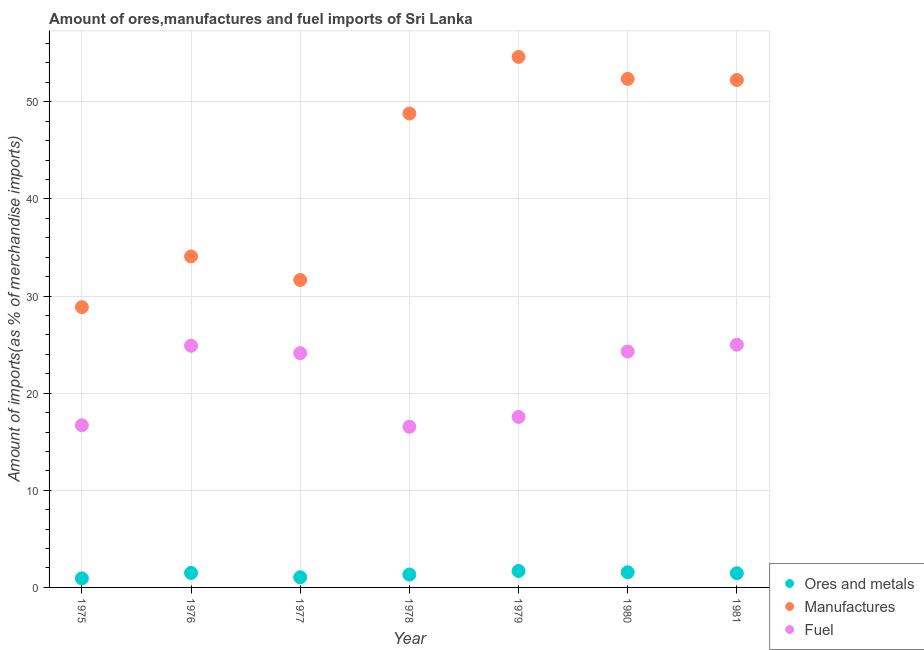Is the number of dotlines equal to the number of legend labels?
Keep it short and to the point. Yes. What is the percentage of manufactures imports in 1979?
Provide a succinct answer. 54.61. Across all years, what is the maximum percentage of ores and metals imports?
Your answer should be very brief. 1.69. Across all years, what is the minimum percentage of fuel imports?
Provide a short and direct response. 16.54. In which year was the percentage of fuel imports maximum?
Your response must be concise. 1981. In which year was the percentage of ores and metals imports minimum?
Make the answer very short. 1975. What is the total percentage of ores and metals imports in the graph?
Make the answer very short. 9.52. What is the difference between the percentage of ores and metals imports in 1977 and that in 1978?
Keep it short and to the point. -0.28. What is the difference between the percentage of ores and metals imports in 1981 and the percentage of fuel imports in 1980?
Provide a short and direct response. -22.83. What is the average percentage of manufactures imports per year?
Keep it short and to the point. 43.22. In the year 1977, what is the difference between the percentage of ores and metals imports and percentage of manufactures imports?
Make the answer very short. -30.6. What is the ratio of the percentage of manufactures imports in 1975 to that in 1980?
Give a very brief answer. 0.55. Is the percentage of fuel imports in 1978 less than that in 1979?
Your answer should be very brief. Yes. What is the difference between the highest and the second highest percentage of fuel imports?
Provide a short and direct response. 0.1. What is the difference between the highest and the lowest percentage of ores and metals imports?
Keep it short and to the point. 0.76. In how many years, is the percentage of fuel imports greater than the average percentage of fuel imports taken over all years?
Give a very brief answer. 4. Is the sum of the percentage of fuel imports in 1975 and 1977 greater than the maximum percentage of ores and metals imports across all years?
Provide a short and direct response. Yes. Does the percentage of ores and metals imports monotonically increase over the years?
Make the answer very short. No. Does the graph contain any zero values?
Ensure brevity in your answer.  No. Where does the legend appear in the graph?
Provide a short and direct response. Bottom right. What is the title of the graph?
Keep it short and to the point. Amount of ores,manufactures and fuel imports of Sri Lanka. What is the label or title of the X-axis?
Give a very brief answer. Year. What is the label or title of the Y-axis?
Provide a succinct answer. Amount of imports(as % of merchandise imports). What is the Amount of imports(as % of merchandise imports) in Ores and metals in 1975?
Provide a succinct answer. 0.93. What is the Amount of imports(as % of merchandise imports) in Manufactures in 1975?
Your answer should be very brief. 28.85. What is the Amount of imports(as % of merchandise imports) of Fuel in 1975?
Offer a very short reply. 16.69. What is the Amount of imports(as % of merchandise imports) in Ores and metals in 1976?
Give a very brief answer. 1.49. What is the Amount of imports(as % of merchandise imports) in Manufactures in 1976?
Offer a terse response. 34.07. What is the Amount of imports(as % of merchandise imports) of Fuel in 1976?
Make the answer very short. 24.88. What is the Amount of imports(as % of merchandise imports) in Ores and metals in 1977?
Ensure brevity in your answer.  1.05. What is the Amount of imports(as % of merchandise imports) in Manufactures in 1977?
Offer a terse response. 31.65. What is the Amount of imports(as % of merchandise imports) in Fuel in 1977?
Provide a short and direct response. 24.12. What is the Amount of imports(as % of merchandise imports) of Ores and metals in 1978?
Give a very brief answer. 1.33. What is the Amount of imports(as % of merchandise imports) in Manufactures in 1978?
Your answer should be very brief. 48.78. What is the Amount of imports(as % of merchandise imports) in Fuel in 1978?
Ensure brevity in your answer.  16.54. What is the Amount of imports(as % of merchandise imports) in Ores and metals in 1979?
Make the answer very short. 1.69. What is the Amount of imports(as % of merchandise imports) in Manufactures in 1979?
Ensure brevity in your answer.  54.61. What is the Amount of imports(as % of merchandise imports) of Fuel in 1979?
Ensure brevity in your answer.  17.55. What is the Amount of imports(as % of merchandise imports) of Ores and metals in 1980?
Offer a very short reply. 1.56. What is the Amount of imports(as % of merchandise imports) of Manufactures in 1980?
Provide a short and direct response. 52.35. What is the Amount of imports(as % of merchandise imports) in Fuel in 1980?
Provide a short and direct response. 24.29. What is the Amount of imports(as % of merchandise imports) of Ores and metals in 1981?
Ensure brevity in your answer.  1.46. What is the Amount of imports(as % of merchandise imports) in Manufactures in 1981?
Offer a very short reply. 52.24. What is the Amount of imports(as % of merchandise imports) of Fuel in 1981?
Ensure brevity in your answer.  24.98. Across all years, what is the maximum Amount of imports(as % of merchandise imports) of Ores and metals?
Provide a succinct answer. 1.69. Across all years, what is the maximum Amount of imports(as % of merchandise imports) in Manufactures?
Provide a short and direct response. 54.61. Across all years, what is the maximum Amount of imports(as % of merchandise imports) in Fuel?
Provide a succinct answer. 24.98. Across all years, what is the minimum Amount of imports(as % of merchandise imports) in Ores and metals?
Offer a very short reply. 0.93. Across all years, what is the minimum Amount of imports(as % of merchandise imports) in Manufactures?
Your answer should be very brief. 28.85. Across all years, what is the minimum Amount of imports(as % of merchandise imports) of Fuel?
Make the answer very short. 16.54. What is the total Amount of imports(as % of merchandise imports) of Ores and metals in the graph?
Give a very brief answer. 9.52. What is the total Amount of imports(as % of merchandise imports) in Manufactures in the graph?
Provide a short and direct response. 302.56. What is the total Amount of imports(as % of merchandise imports) of Fuel in the graph?
Provide a succinct answer. 149.04. What is the difference between the Amount of imports(as % of merchandise imports) in Ores and metals in 1975 and that in 1976?
Offer a terse response. -0.56. What is the difference between the Amount of imports(as % of merchandise imports) in Manufactures in 1975 and that in 1976?
Provide a short and direct response. -5.22. What is the difference between the Amount of imports(as % of merchandise imports) of Fuel in 1975 and that in 1976?
Make the answer very short. -8.19. What is the difference between the Amount of imports(as % of merchandise imports) in Ores and metals in 1975 and that in 1977?
Ensure brevity in your answer.  -0.11. What is the difference between the Amount of imports(as % of merchandise imports) of Manufactures in 1975 and that in 1977?
Keep it short and to the point. -2.8. What is the difference between the Amount of imports(as % of merchandise imports) of Fuel in 1975 and that in 1977?
Your answer should be compact. -7.43. What is the difference between the Amount of imports(as % of merchandise imports) in Ores and metals in 1975 and that in 1978?
Your response must be concise. -0.4. What is the difference between the Amount of imports(as % of merchandise imports) in Manufactures in 1975 and that in 1978?
Offer a very short reply. -19.93. What is the difference between the Amount of imports(as % of merchandise imports) of Fuel in 1975 and that in 1978?
Give a very brief answer. 0.15. What is the difference between the Amount of imports(as % of merchandise imports) of Ores and metals in 1975 and that in 1979?
Offer a very short reply. -0.76. What is the difference between the Amount of imports(as % of merchandise imports) in Manufactures in 1975 and that in 1979?
Your response must be concise. -25.76. What is the difference between the Amount of imports(as % of merchandise imports) of Fuel in 1975 and that in 1979?
Your response must be concise. -0.86. What is the difference between the Amount of imports(as % of merchandise imports) of Ores and metals in 1975 and that in 1980?
Provide a succinct answer. -0.63. What is the difference between the Amount of imports(as % of merchandise imports) in Manufactures in 1975 and that in 1980?
Provide a succinct answer. -23.5. What is the difference between the Amount of imports(as % of merchandise imports) in Fuel in 1975 and that in 1980?
Your response must be concise. -7.6. What is the difference between the Amount of imports(as % of merchandise imports) of Ores and metals in 1975 and that in 1981?
Ensure brevity in your answer.  -0.53. What is the difference between the Amount of imports(as % of merchandise imports) of Manufactures in 1975 and that in 1981?
Provide a short and direct response. -23.38. What is the difference between the Amount of imports(as % of merchandise imports) in Fuel in 1975 and that in 1981?
Provide a short and direct response. -8.29. What is the difference between the Amount of imports(as % of merchandise imports) in Ores and metals in 1976 and that in 1977?
Your answer should be very brief. 0.44. What is the difference between the Amount of imports(as % of merchandise imports) in Manufactures in 1976 and that in 1977?
Provide a short and direct response. 2.43. What is the difference between the Amount of imports(as % of merchandise imports) of Fuel in 1976 and that in 1977?
Keep it short and to the point. 0.76. What is the difference between the Amount of imports(as % of merchandise imports) of Ores and metals in 1976 and that in 1978?
Keep it short and to the point. 0.16. What is the difference between the Amount of imports(as % of merchandise imports) in Manufactures in 1976 and that in 1978?
Provide a succinct answer. -14.71. What is the difference between the Amount of imports(as % of merchandise imports) in Fuel in 1976 and that in 1978?
Offer a terse response. 8.34. What is the difference between the Amount of imports(as % of merchandise imports) of Ores and metals in 1976 and that in 1979?
Provide a succinct answer. -0.2. What is the difference between the Amount of imports(as % of merchandise imports) in Manufactures in 1976 and that in 1979?
Your answer should be very brief. -20.54. What is the difference between the Amount of imports(as % of merchandise imports) of Fuel in 1976 and that in 1979?
Offer a very short reply. 7.33. What is the difference between the Amount of imports(as % of merchandise imports) of Ores and metals in 1976 and that in 1980?
Provide a succinct answer. -0.07. What is the difference between the Amount of imports(as % of merchandise imports) in Manufactures in 1976 and that in 1980?
Offer a very short reply. -18.27. What is the difference between the Amount of imports(as % of merchandise imports) of Fuel in 1976 and that in 1980?
Offer a terse response. 0.59. What is the difference between the Amount of imports(as % of merchandise imports) of Ores and metals in 1976 and that in 1981?
Provide a short and direct response. 0.03. What is the difference between the Amount of imports(as % of merchandise imports) of Manufactures in 1976 and that in 1981?
Keep it short and to the point. -18.16. What is the difference between the Amount of imports(as % of merchandise imports) in Fuel in 1976 and that in 1981?
Your answer should be compact. -0.1. What is the difference between the Amount of imports(as % of merchandise imports) in Ores and metals in 1977 and that in 1978?
Your response must be concise. -0.28. What is the difference between the Amount of imports(as % of merchandise imports) of Manufactures in 1977 and that in 1978?
Offer a very short reply. -17.13. What is the difference between the Amount of imports(as % of merchandise imports) in Fuel in 1977 and that in 1978?
Your answer should be compact. 7.58. What is the difference between the Amount of imports(as % of merchandise imports) of Ores and metals in 1977 and that in 1979?
Give a very brief answer. -0.65. What is the difference between the Amount of imports(as % of merchandise imports) in Manufactures in 1977 and that in 1979?
Ensure brevity in your answer.  -22.97. What is the difference between the Amount of imports(as % of merchandise imports) in Fuel in 1977 and that in 1979?
Offer a terse response. 6.57. What is the difference between the Amount of imports(as % of merchandise imports) in Ores and metals in 1977 and that in 1980?
Offer a very short reply. -0.51. What is the difference between the Amount of imports(as % of merchandise imports) in Manufactures in 1977 and that in 1980?
Offer a terse response. -20.7. What is the difference between the Amount of imports(as % of merchandise imports) in Fuel in 1977 and that in 1980?
Make the answer very short. -0.17. What is the difference between the Amount of imports(as % of merchandise imports) in Ores and metals in 1977 and that in 1981?
Make the answer very short. -0.42. What is the difference between the Amount of imports(as % of merchandise imports) in Manufactures in 1977 and that in 1981?
Give a very brief answer. -20.59. What is the difference between the Amount of imports(as % of merchandise imports) of Fuel in 1977 and that in 1981?
Offer a very short reply. -0.87. What is the difference between the Amount of imports(as % of merchandise imports) in Ores and metals in 1978 and that in 1979?
Offer a terse response. -0.36. What is the difference between the Amount of imports(as % of merchandise imports) of Manufactures in 1978 and that in 1979?
Your response must be concise. -5.83. What is the difference between the Amount of imports(as % of merchandise imports) in Fuel in 1978 and that in 1979?
Your answer should be compact. -1.01. What is the difference between the Amount of imports(as % of merchandise imports) of Ores and metals in 1978 and that in 1980?
Provide a short and direct response. -0.23. What is the difference between the Amount of imports(as % of merchandise imports) of Manufactures in 1978 and that in 1980?
Keep it short and to the point. -3.57. What is the difference between the Amount of imports(as % of merchandise imports) in Fuel in 1978 and that in 1980?
Ensure brevity in your answer.  -7.75. What is the difference between the Amount of imports(as % of merchandise imports) of Ores and metals in 1978 and that in 1981?
Your answer should be compact. -0.13. What is the difference between the Amount of imports(as % of merchandise imports) in Manufactures in 1978 and that in 1981?
Make the answer very short. -3.45. What is the difference between the Amount of imports(as % of merchandise imports) of Fuel in 1978 and that in 1981?
Your answer should be very brief. -8.44. What is the difference between the Amount of imports(as % of merchandise imports) of Ores and metals in 1979 and that in 1980?
Make the answer very short. 0.13. What is the difference between the Amount of imports(as % of merchandise imports) of Manufactures in 1979 and that in 1980?
Give a very brief answer. 2.27. What is the difference between the Amount of imports(as % of merchandise imports) of Fuel in 1979 and that in 1980?
Offer a terse response. -6.74. What is the difference between the Amount of imports(as % of merchandise imports) of Ores and metals in 1979 and that in 1981?
Your answer should be compact. 0.23. What is the difference between the Amount of imports(as % of merchandise imports) of Manufactures in 1979 and that in 1981?
Ensure brevity in your answer.  2.38. What is the difference between the Amount of imports(as % of merchandise imports) in Fuel in 1979 and that in 1981?
Give a very brief answer. -7.43. What is the difference between the Amount of imports(as % of merchandise imports) of Ores and metals in 1980 and that in 1981?
Offer a very short reply. 0.1. What is the difference between the Amount of imports(as % of merchandise imports) in Manufactures in 1980 and that in 1981?
Provide a succinct answer. 0.11. What is the difference between the Amount of imports(as % of merchandise imports) in Fuel in 1980 and that in 1981?
Make the answer very short. -0.69. What is the difference between the Amount of imports(as % of merchandise imports) of Ores and metals in 1975 and the Amount of imports(as % of merchandise imports) of Manufactures in 1976?
Provide a succinct answer. -33.14. What is the difference between the Amount of imports(as % of merchandise imports) of Ores and metals in 1975 and the Amount of imports(as % of merchandise imports) of Fuel in 1976?
Provide a succinct answer. -23.95. What is the difference between the Amount of imports(as % of merchandise imports) in Manufactures in 1975 and the Amount of imports(as % of merchandise imports) in Fuel in 1976?
Your response must be concise. 3.97. What is the difference between the Amount of imports(as % of merchandise imports) of Ores and metals in 1975 and the Amount of imports(as % of merchandise imports) of Manufactures in 1977?
Provide a short and direct response. -30.72. What is the difference between the Amount of imports(as % of merchandise imports) of Ores and metals in 1975 and the Amount of imports(as % of merchandise imports) of Fuel in 1977?
Provide a succinct answer. -23.18. What is the difference between the Amount of imports(as % of merchandise imports) of Manufactures in 1975 and the Amount of imports(as % of merchandise imports) of Fuel in 1977?
Your answer should be very brief. 4.74. What is the difference between the Amount of imports(as % of merchandise imports) of Ores and metals in 1975 and the Amount of imports(as % of merchandise imports) of Manufactures in 1978?
Offer a terse response. -47.85. What is the difference between the Amount of imports(as % of merchandise imports) in Ores and metals in 1975 and the Amount of imports(as % of merchandise imports) in Fuel in 1978?
Offer a very short reply. -15.61. What is the difference between the Amount of imports(as % of merchandise imports) in Manufactures in 1975 and the Amount of imports(as % of merchandise imports) in Fuel in 1978?
Your answer should be compact. 12.31. What is the difference between the Amount of imports(as % of merchandise imports) of Ores and metals in 1975 and the Amount of imports(as % of merchandise imports) of Manufactures in 1979?
Your answer should be very brief. -53.68. What is the difference between the Amount of imports(as % of merchandise imports) of Ores and metals in 1975 and the Amount of imports(as % of merchandise imports) of Fuel in 1979?
Ensure brevity in your answer.  -16.62. What is the difference between the Amount of imports(as % of merchandise imports) in Manufactures in 1975 and the Amount of imports(as % of merchandise imports) in Fuel in 1979?
Your answer should be compact. 11.3. What is the difference between the Amount of imports(as % of merchandise imports) of Ores and metals in 1975 and the Amount of imports(as % of merchandise imports) of Manufactures in 1980?
Give a very brief answer. -51.42. What is the difference between the Amount of imports(as % of merchandise imports) of Ores and metals in 1975 and the Amount of imports(as % of merchandise imports) of Fuel in 1980?
Your response must be concise. -23.36. What is the difference between the Amount of imports(as % of merchandise imports) of Manufactures in 1975 and the Amount of imports(as % of merchandise imports) of Fuel in 1980?
Give a very brief answer. 4.56. What is the difference between the Amount of imports(as % of merchandise imports) of Ores and metals in 1975 and the Amount of imports(as % of merchandise imports) of Manufactures in 1981?
Keep it short and to the point. -51.3. What is the difference between the Amount of imports(as % of merchandise imports) in Ores and metals in 1975 and the Amount of imports(as % of merchandise imports) in Fuel in 1981?
Offer a very short reply. -24.05. What is the difference between the Amount of imports(as % of merchandise imports) in Manufactures in 1975 and the Amount of imports(as % of merchandise imports) in Fuel in 1981?
Make the answer very short. 3.87. What is the difference between the Amount of imports(as % of merchandise imports) in Ores and metals in 1976 and the Amount of imports(as % of merchandise imports) in Manufactures in 1977?
Your answer should be very brief. -30.16. What is the difference between the Amount of imports(as % of merchandise imports) of Ores and metals in 1976 and the Amount of imports(as % of merchandise imports) of Fuel in 1977?
Ensure brevity in your answer.  -22.62. What is the difference between the Amount of imports(as % of merchandise imports) in Manufactures in 1976 and the Amount of imports(as % of merchandise imports) in Fuel in 1977?
Your answer should be compact. 9.96. What is the difference between the Amount of imports(as % of merchandise imports) of Ores and metals in 1976 and the Amount of imports(as % of merchandise imports) of Manufactures in 1978?
Offer a very short reply. -47.29. What is the difference between the Amount of imports(as % of merchandise imports) of Ores and metals in 1976 and the Amount of imports(as % of merchandise imports) of Fuel in 1978?
Provide a succinct answer. -15.05. What is the difference between the Amount of imports(as % of merchandise imports) of Manufactures in 1976 and the Amount of imports(as % of merchandise imports) of Fuel in 1978?
Offer a terse response. 17.54. What is the difference between the Amount of imports(as % of merchandise imports) of Ores and metals in 1976 and the Amount of imports(as % of merchandise imports) of Manufactures in 1979?
Ensure brevity in your answer.  -53.12. What is the difference between the Amount of imports(as % of merchandise imports) of Ores and metals in 1976 and the Amount of imports(as % of merchandise imports) of Fuel in 1979?
Offer a terse response. -16.06. What is the difference between the Amount of imports(as % of merchandise imports) of Manufactures in 1976 and the Amount of imports(as % of merchandise imports) of Fuel in 1979?
Your answer should be very brief. 16.52. What is the difference between the Amount of imports(as % of merchandise imports) of Ores and metals in 1976 and the Amount of imports(as % of merchandise imports) of Manufactures in 1980?
Offer a very short reply. -50.86. What is the difference between the Amount of imports(as % of merchandise imports) of Ores and metals in 1976 and the Amount of imports(as % of merchandise imports) of Fuel in 1980?
Your response must be concise. -22.8. What is the difference between the Amount of imports(as % of merchandise imports) of Manufactures in 1976 and the Amount of imports(as % of merchandise imports) of Fuel in 1980?
Keep it short and to the point. 9.78. What is the difference between the Amount of imports(as % of merchandise imports) in Ores and metals in 1976 and the Amount of imports(as % of merchandise imports) in Manufactures in 1981?
Your answer should be compact. -50.75. What is the difference between the Amount of imports(as % of merchandise imports) in Ores and metals in 1976 and the Amount of imports(as % of merchandise imports) in Fuel in 1981?
Offer a very short reply. -23.49. What is the difference between the Amount of imports(as % of merchandise imports) of Manufactures in 1976 and the Amount of imports(as % of merchandise imports) of Fuel in 1981?
Make the answer very short. 9.09. What is the difference between the Amount of imports(as % of merchandise imports) in Ores and metals in 1977 and the Amount of imports(as % of merchandise imports) in Manufactures in 1978?
Offer a very short reply. -47.74. What is the difference between the Amount of imports(as % of merchandise imports) of Ores and metals in 1977 and the Amount of imports(as % of merchandise imports) of Fuel in 1978?
Give a very brief answer. -15.49. What is the difference between the Amount of imports(as % of merchandise imports) of Manufactures in 1977 and the Amount of imports(as % of merchandise imports) of Fuel in 1978?
Give a very brief answer. 15.11. What is the difference between the Amount of imports(as % of merchandise imports) of Ores and metals in 1977 and the Amount of imports(as % of merchandise imports) of Manufactures in 1979?
Your response must be concise. -53.57. What is the difference between the Amount of imports(as % of merchandise imports) of Ores and metals in 1977 and the Amount of imports(as % of merchandise imports) of Fuel in 1979?
Your answer should be compact. -16.5. What is the difference between the Amount of imports(as % of merchandise imports) in Manufactures in 1977 and the Amount of imports(as % of merchandise imports) in Fuel in 1979?
Ensure brevity in your answer.  14.1. What is the difference between the Amount of imports(as % of merchandise imports) in Ores and metals in 1977 and the Amount of imports(as % of merchandise imports) in Manufactures in 1980?
Offer a very short reply. -51.3. What is the difference between the Amount of imports(as % of merchandise imports) in Ores and metals in 1977 and the Amount of imports(as % of merchandise imports) in Fuel in 1980?
Your response must be concise. -23.24. What is the difference between the Amount of imports(as % of merchandise imports) of Manufactures in 1977 and the Amount of imports(as % of merchandise imports) of Fuel in 1980?
Make the answer very short. 7.36. What is the difference between the Amount of imports(as % of merchandise imports) of Ores and metals in 1977 and the Amount of imports(as % of merchandise imports) of Manufactures in 1981?
Provide a short and direct response. -51.19. What is the difference between the Amount of imports(as % of merchandise imports) in Ores and metals in 1977 and the Amount of imports(as % of merchandise imports) in Fuel in 1981?
Offer a very short reply. -23.94. What is the difference between the Amount of imports(as % of merchandise imports) in Manufactures in 1977 and the Amount of imports(as % of merchandise imports) in Fuel in 1981?
Offer a terse response. 6.67. What is the difference between the Amount of imports(as % of merchandise imports) of Ores and metals in 1978 and the Amount of imports(as % of merchandise imports) of Manufactures in 1979?
Your answer should be compact. -53.29. What is the difference between the Amount of imports(as % of merchandise imports) of Ores and metals in 1978 and the Amount of imports(as % of merchandise imports) of Fuel in 1979?
Make the answer very short. -16.22. What is the difference between the Amount of imports(as % of merchandise imports) of Manufactures in 1978 and the Amount of imports(as % of merchandise imports) of Fuel in 1979?
Offer a very short reply. 31.23. What is the difference between the Amount of imports(as % of merchandise imports) of Ores and metals in 1978 and the Amount of imports(as % of merchandise imports) of Manufactures in 1980?
Give a very brief answer. -51.02. What is the difference between the Amount of imports(as % of merchandise imports) in Ores and metals in 1978 and the Amount of imports(as % of merchandise imports) in Fuel in 1980?
Ensure brevity in your answer.  -22.96. What is the difference between the Amount of imports(as % of merchandise imports) of Manufactures in 1978 and the Amount of imports(as % of merchandise imports) of Fuel in 1980?
Offer a very short reply. 24.49. What is the difference between the Amount of imports(as % of merchandise imports) of Ores and metals in 1978 and the Amount of imports(as % of merchandise imports) of Manufactures in 1981?
Your response must be concise. -50.91. What is the difference between the Amount of imports(as % of merchandise imports) of Ores and metals in 1978 and the Amount of imports(as % of merchandise imports) of Fuel in 1981?
Offer a terse response. -23.65. What is the difference between the Amount of imports(as % of merchandise imports) of Manufactures in 1978 and the Amount of imports(as % of merchandise imports) of Fuel in 1981?
Offer a terse response. 23.8. What is the difference between the Amount of imports(as % of merchandise imports) of Ores and metals in 1979 and the Amount of imports(as % of merchandise imports) of Manufactures in 1980?
Your answer should be very brief. -50.66. What is the difference between the Amount of imports(as % of merchandise imports) in Ores and metals in 1979 and the Amount of imports(as % of merchandise imports) in Fuel in 1980?
Offer a very short reply. -22.6. What is the difference between the Amount of imports(as % of merchandise imports) in Manufactures in 1979 and the Amount of imports(as % of merchandise imports) in Fuel in 1980?
Give a very brief answer. 30.32. What is the difference between the Amount of imports(as % of merchandise imports) of Ores and metals in 1979 and the Amount of imports(as % of merchandise imports) of Manufactures in 1981?
Ensure brevity in your answer.  -50.54. What is the difference between the Amount of imports(as % of merchandise imports) in Ores and metals in 1979 and the Amount of imports(as % of merchandise imports) in Fuel in 1981?
Give a very brief answer. -23.29. What is the difference between the Amount of imports(as % of merchandise imports) in Manufactures in 1979 and the Amount of imports(as % of merchandise imports) in Fuel in 1981?
Offer a very short reply. 29.63. What is the difference between the Amount of imports(as % of merchandise imports) of Ores and metals in 1980 and the Amount of imports(as % of merchandise imports) of Manufactures in 1981?
Provide a succinct answer. -50.68. What is the difference between the Amount of imports(as % of merchandise imports) in Ores and metals in 1980 and the Amount of imports(as % of merchandise imports) in Fuel in 1981?
Offer a terse response. -23.42. What is the difference between the Amount of imports(as % of merchandise imports) in Manufactures in 1980 and the Amount of imports(as % of merchandise imports) in Fuel in 1981?
Give a very brief answer. 27.37. What is the average Amount of imports(as % of merchandise imports) in Ores and metals per year?
Your answer should be compact. 1.36. What is the average Amount of imports(as % of merchandise imports) of Manufactures per year?
Ensure brevity in your answer.  43.22. What is the average Amount of imports(as % of merchandise imports) in Fuel per year?
Provide a succinct answer. 21.29. In the year 1975, what is the difference between the Amount of imports(as % of merchandise imports) of Ores and metals and Amount of imports(as % of merchandise imports) of Manufactures?
Provide a short and direct response. -27.92. In the year 1975, what is the difference between the Amount of imports(as % of merchandise imports) in Ores and metals and Amount of imports(as % of merchandise imports) in Fuel?
Make the answer very short. -15.76. In the year 1975, what is the difference between the Amount of imports(as % of merchandise imports) in Manufactures and Amount of imports(as % of merchandise imports) in Fuel?
Give a very brief answer. 12.16. In the year 1976, what is the difference between the Amount of imports(as % of merchandise imports) in Ores and metals and Amount of imports(as % of merchandise imports) in Manufactures?
Your response must be concise. -32.58. In the year 1976, what is the difference between the Amount of imports(as % of merchandise imports) in Ores and metals and Amount of imports(as % of merchandise imports) in Fuel?
Your answer should be very brief. -23.39. In the year 1976, what is the difference between the Amount of imports(as % of merchandise imports) of Manufactures and Amount of imports(as % of merchandise imports) of Fuel?
Ensure brevity in your answer.  9.2. In the year 1977, what is the difference between the Amount of imports(as % of merchandise imports) of Ores and metals and Amount of imports(as % of merchandise imports) of Manufactures?
Make the answer very short. -30.6. In the year 1977, what is the difference between the Amount of imports(as % of merchandise imports) in Ores and metals and Amount of imports(as % of merchandise imports) in Fuel?
Your response must be concise. -23.07. In the year 1977, what is the difference between the Amount of imports(as % of merchandise imports) of Manufactures and Amount of imports(as % of merchandise imports) of Fuel?
Offer a very short reply. 7.53. In the year 1978, what is the difference between the Amount of imports(as % of merchandise imports) in Ores and metals and Amount of imports(as % of merchandise imports) in Manufactures?
Make the answer very short. -47.45. In the year 1978, what is the difference between the Amount of imports(as % of merchandise imports) of Ores and metals and Amount of imports(as % of merchandise imports) of Fuel?
Your answer should be very brief. -15.21. In the year 1978, what is the difference between the Amount of imports(as % of merchandise imports) in Manufactures and Amount of imports(as % of merchandise imports) in Fuel?
Provide a succinct answer. 32.24. In the year 1979, what is the difference between the Amount of imports(as % of merchandise imports) in Ores and metals and Amount of imports(as % of merchandise imports) in Manufactures?
Provide a succinct answer. -52.92. In the year 1979, what is the difference between the Amount of imports(as % of merchandise imports) in Ores and metals and Amount of imports(as % of merchandise imports) in Fuel?
Give a very brief answer. -15.86. In the year 1979, what is the difference between the Amount of imports(as % of merchandise imports) in Manufactures and Amount of imports(as % of merchandise imports) in Fuel?
Ensure brevity in your answer.  37.06. In the year 1980, what is the difference between the Amount of imports(as % of merchandise imports) in Ores and metals and Amount of imports(as % of merchandise imports) in Manufactures?
Provide a succinct answer. -50.79. In the year 1980, what is the difference between the Amount of imports(as % of merchandise imports) in Ores and metals and Amount of imports(as % of merchandise imports) in Fuel?
Provide a short and direct response. -22.73. In the year 1980, what is the difference between the Amount of imports(as % of merchandise imports) of Manufactures and Amount of imports(as % of merchandise imports) of Fuel?
Your answer should be compact. 28.06. In the year 1981, what is the difference between the Amount of imports(as % of merchandise imports) in Ores and metals and Amount of imports(as % of merchandise imports) in Manufactures?
Ensure brevity in your answer.  -50.77. In the year 1981, what is the difference between the Amount of imports(as % of merchandise imports) in Ores and metals and Amount of imports(as % of merchandise imports) in Fuel?
Your answer should be compact. -23.52. In the year 1981, what is the difference between the Amount of imports(as % of merchandise imports) in Manufactures and Amount of imports(as % of merchandise imports) in Fuel?
Offer a terse response. 27.25. What is the ratio of the Amount of imports(as % of merchandise imports) in Ores and metals in 1975 to that in 1976?
Offer a terse response. 0.63. What is the ratio of the Amount of imports(as % of merchandise imports) in Manufactures in 1975 to that in 1976?
Offer a very short reply. 0.85. What is the ratio of the Amount of imports(as % of merchandise imports) in Fuel in 1975 to that in 1976?
Your answer should be compact. 0.67. What is the ratio of the Amount of imports(as % of merchandise imports) of Ores and metals in 1975 to that in 1977?
Your answer should be very brief. 0.89. What is the ratio of the Amount of imports(as % of merchandise imports) in Manufactures in 1975 to that in 1977?
Your answer should be compact. 0.91. What is the ratio of the Amount of imports(as % of merchandise imports) of Fuel in 1975 to that in 1977?
Your answer should be compact. 0.69. What is the ratio of the Amount of imports(as % of merchandise imports) of Ores and metals in 1975 to that in 1978?
Keep it short and to the point. 0.7. What is the ratio of the Amount of imports(as % of merchandise imports) in Manufactures in 1975 to that in 1978?
Your answer should be very brief. 0.59. What is the ratio of the Amount of imports(as % of merchandise imports) of Fuel in 1975 to that in 1978?
Ensure brevity in your answer.  1.01. What is the ratio of the Amount of imports(as % of merchandise imports) of Ores and metals in 1975 to that in 1979?
Your response must be concise. 0.55. What is the ratio of the Amount of imports(as % of merchandise imports) of Manufactures in 1975 to that in 1979?
Your answer should be very brief. 0.53. What is the ratio of the Amount of imports(as % of merchandise imports) of Fuel in 1975 to that in 1979?
Offer a very short reply. 0.95. What is the ratio of the Amount of imports(as % of merchandise imports) of Ores and metals in 1975 to that in 1980?
Keep it short and to the point. 0.6. What is the ratio of the Amount of imports(as % of merchandise imports) of Manufactures in 1975 to that in 1980?
Ensure brevity in your answer.  0.55. What is the ratio of the Amount of imports(as % of merchandise imports) of Fuel in 1975 to that in 1980?
Your answer should be compact. 0.69. What is the ratio of the Amount of imports(as % of merchandise imports) of Ores and metals in 1975 to that in 1981?
Ensure brevity in your answer.  0.64. What is the ratio of the Amount of imports(as % of merchandise imports) in Manufactures in 1975 to that in 1981?
Provide a short and direct response. 0.55. What is the ratio of the Amount of imports(as % of merchandise imports) of Fuel in 1975 to that in 1981?
Provide a short and direct response. 0.67. What is the ratio of the Amount of imports(as % of merchandise imports) in Ores and metals in 1976 to that in 1977?
Ensure brevity in your answer.  1.43. What is the ratio of the Amount of imports(as % of merchandise imports) in Manufactures in 1976 to that in 1977?
Offer a very short reply. 1.08. What is the ratio of the Amount of imports(as % of merchandise imports) in Fuel in 1976 to that in 1977?
Give a very brief answer. 1.03. What is the ratio of the Amount of imports(as % of merchandise imports) in Ores and metals in 1976 to that in 1978?
Provide a succinct answer. 1.12. What is the ratio of the Amount of imports(as % of merchandise imports) in Manufactures in 1976 to that in 1978?
Provide a short and direct response. 0.7. What is the ratio of the Amount of imports(as % of merchandise imports) of Fuel in 1976 to that in 1978?
Keep it short and to the point. 1.5. What is the ratio of the Amount of imports(as % of merchandise imports) in Ores and metals in 1976 to that in 1979?
Your answer should be compact. 0.88. What is the ratio of the Amount of imports(as % of merchandise imports) in Manufactures in 1976 to that in 1979?
Offer a terse response. 0.62. What is the ratio of the Amount of imports(as % of merchandise imports) of Fuel in 1976 to that in 1979?
Keep it short and to the point. 1.42. What is the ratio of the Amount of imports(as % of merchandise imports) of Ores and metals in 1976 to that in 1980?
Keep it short and to the point. 0.96. What is the ratio of the Amount of imports(as % of merchandise imports) in Manufactures in 1976 to that in 1980?
Offer a terse response. 0.65. What is the ratio of the Amount of imports(as % of merchandise imports) of Fuel in 1976 to that in 1980?
Your response must be concise. 1.02. What is the ratio of the Amount of imports(as % of merchandise imports) of Ores and metals in 1976 to that in 1981?
Your answer should be very brief. 1.02. What is the ratio of the Amount of imports(as % of merchandise imports) in Manufactures in 1976 to that in 1981?
Provide a succinct answer. 0.65. What is the ratio of the Amount of imports(as % of merchandise imports) in Fuel in 1976 to that in 1981?
Your answer should be very brief. 1. What is the ratio of the Amount of imports(as % of merchandise imports) of Ores and metals in 1977 to that in 1978?
Offer a very short reply. 0.79. What is the ratio of the Amount of imports(as % of merchandise imports) of Manufactures in 1977 to that in 1978?
Your answer should be very brief. 0.65. What is the ratio of the Amount of imports(as % of merchandise imports) of Fuel in 1977 to that in 1978?
Ensure brevity in your answer.  1.46. What is the ratio of the Amount of imports(as % of merchandise imports) in Ores and metals in 1977 to that in 1979?
Offer a terse response. 0.62. What is the ratio of the Amount of imports(as % of merchandise imports) in Manufactures in 1977 to that in 1979?
Ensure brevity in your answer.  0.58. What is the ratio of the Amount of imports(as % of merchandise imports) in Fuel in 1977 to that in 1979?
Keep it short and to the point. 1.37. What is the ratio of the Amount of imports(as % of merchandise imports) in Ores and metals in 1977 to that in 1980?
Keep it short and to the point. 0.67. What is the ratio of the Amount of imports(as % of merchandise imports) in Manufactures in 1977 to that in 1980?
Make the answer very short. 0.6. What is the ratio of the Amount of imports(as % of merchandise imports) in Ores and metals in 1977 to that in 1981?
Give a very brief answer. 0.72. What is the ratio of the Amount of imports(as % of merchandise imports) of Manufactures in 1977 to that in 1981?
Keep it short and to the point. 0.61. What is the ratio of the Amount of imports(as % of merchandise imports) in Fuel in 1977 to that in 1981?
Offer a terse response. 0.97. What is the ratio of the Amount of imports(as % of merchandise imports) in Ores and metals in 1978 to that in 1979?
Your answer should be very brief. 0.78. What is the ratio of the Amount of imports(as % of merchandise imports) of Manufactures in 1978 to that in 1979?
Provide a succinct answer. 0.89. What is the ratio of the Amount of imports(as % of merchandise imports) of Fuel in 1978 to that in 1979?
Your answer should be compact. 0.94. What is the ratio of the Amount of imports(as % of merchandise imports) in Ores and metals in 1978 to that in 1980?
Your answer should be very brief. 0.85. What is the ratio of the Amount of imports(as % of merchandise imports) in Manufactures in 1978 to that in 1980?
Provide a succinct answer. 0.93. What is the ratio of the Amount of imports(as % of merchandise imports) in Fuel in 1978 to that in 1980?
Provide a succinct answer. 0.68. What is the ratio of the Amount of imports(as % of merchandise imports) of Ores and metals in 1978 to that in 1981?
Offer a very short reply. 0.91. What is the ratio of the Amount of imports(as % of merchandise imports) in Manufactures in 1978 to that in 1981?
Your answer should be very brief. 0.93. What is the ratio of the Amount of imports(as % of merchandise imports) of Fuel in 1978 to that in 1981?
Give a very brief answer. 0.66. What is the ratio of the Amount of imports(as % of merchandise imports) in Ores and metals in 1979 to that in 1980?
Provide a succinct answer. 1.08. What is the ratio of the Amount of imports(as % of merchandise imports) in Manufactures in 1979 to that in 1980?
Offer a terse response. 1.04. What is the ratio of the Amount of imports(as % of merchandise imports) of Fuel in 1979 to that in 1980?
Your answer should be very brief. 0.72. What is the ratio of the Amount of imports(as % of merchandise imports) of Ores and metals in 1979 to that in 1981?
Provide a succinct answer. 1.16. What is the ratio of the Amount of imports(as % of merchandise imports) in Manufactures in 1979 to that in 1981?
Provide a succinct answer. 1.05. What is the ratio of the Amount of imports(as % of merchandise imports) in Fuel in 1979 to that in 1981?
Provide a succinct answer. 0.7. What is the ratio of the Amount of imports(as % of merchandise imports) in Ores and metals in 1980 to that in 1981?
Offer a very short reply. 1.07. What is the ratio of the Amount of imports(as % of merchandise imports) of Manufactures in 1980 to that in 1981?
Provide a short and direct response. 1. What is the ratio of the Amount of imports(as % of merchandise imports) of Fuel in 1980 to that in 1981?
Your answer should be very brief. 0.97. What is the difference between the highest and the second highest Amount of imports(as % of merchandise imports) of Ores and metals?
Your answer should be very brief. 0.13. What is the difference between the highest and the second highest Amount of imports(as % of merchandise imports) of Manufactures?
Your answer should be very brief. 2.27. What is the difference between the highest and the second highest Amount of imports(as % of merchandise imports) in Fuel?
Make the answer very short. 0.1. What is the difference between the highest and the lowest Amount of imports(as % of merchandise imports) of Ores and metals?
Keep it short and to the point. 0.76. What is the difference between the highest and the lowest Amount of imports(as % of merchandise imports) of Manufactures?
Your answer should be very brief. 25.76. What is the difference between the highest and the lowest Amount of imports(as % of merchandise imports) of Fuel?
Keep it short and to the point. 8.44. 